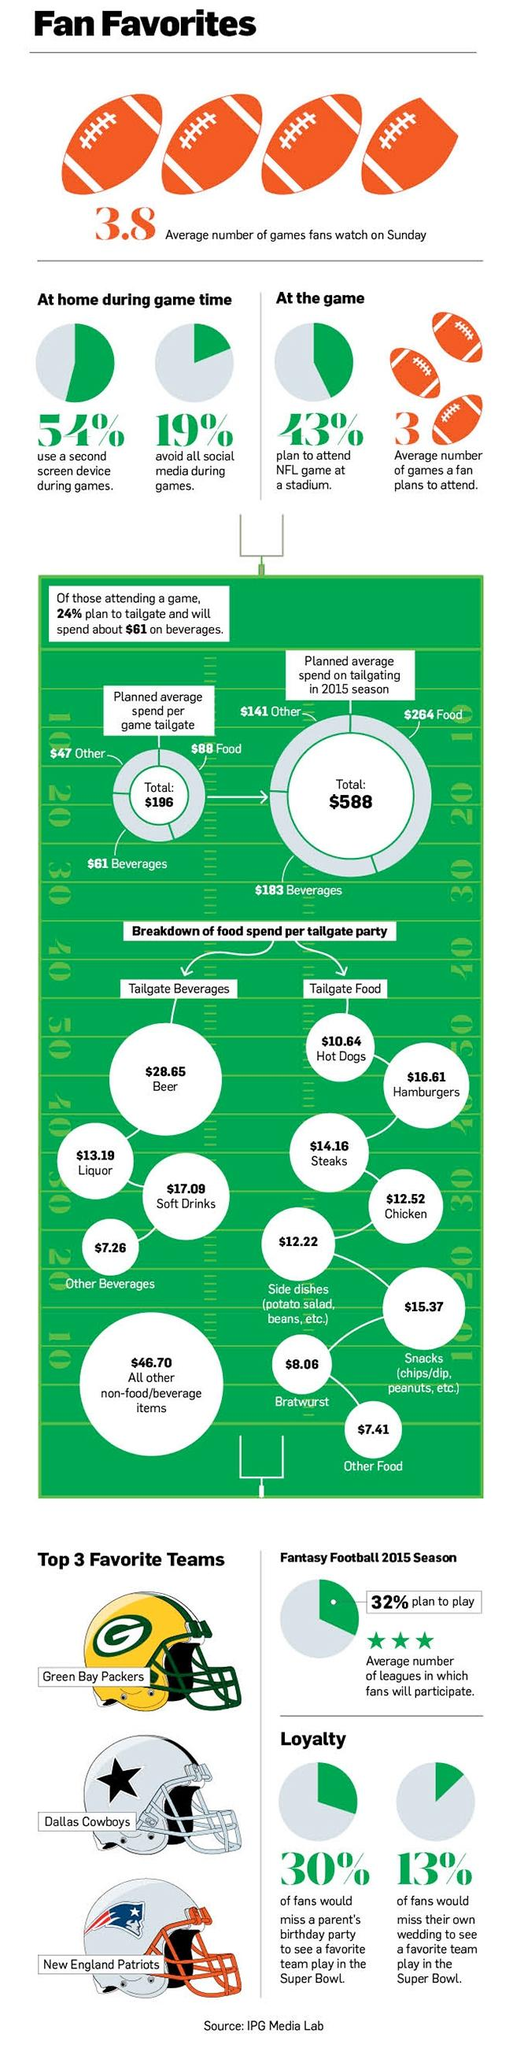Highlight a few significant elements in this photo. In 2015, the average amount spent on food and beverages was $447. In total, the delegate parties spent $41.84 on beer and liquor per person. The total amount spent per delegate party on hot dogs and hamburgers was $27.25. The total amount spent per delegate party on steaks and chicken in dollars was 26.68. 